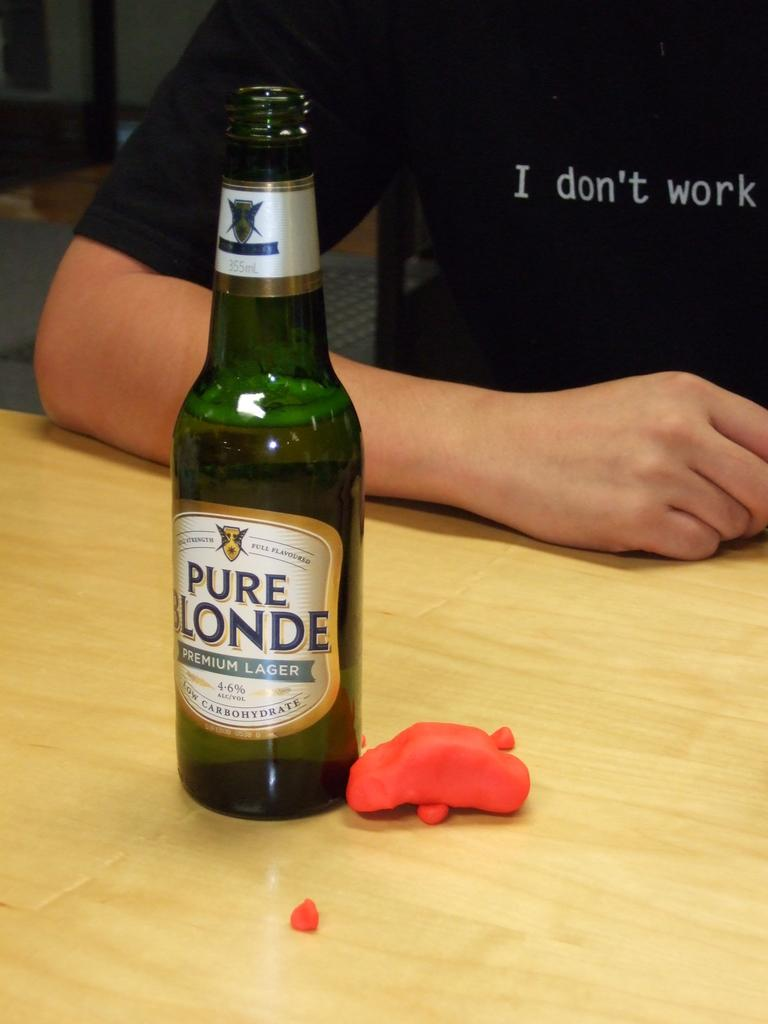What object is on the table in the image? There is a glass bottle on the table in the image. Can you describe the person in the image? The person in the image is wearing a black t-shirt. What type of suit is the horse wearing in the image? There is no horse present in the image, and therefore no suit can be observed. What experience does the person have with the glass bottle in the image? The image does not provide any information about the person's experience with the glass bottle. 